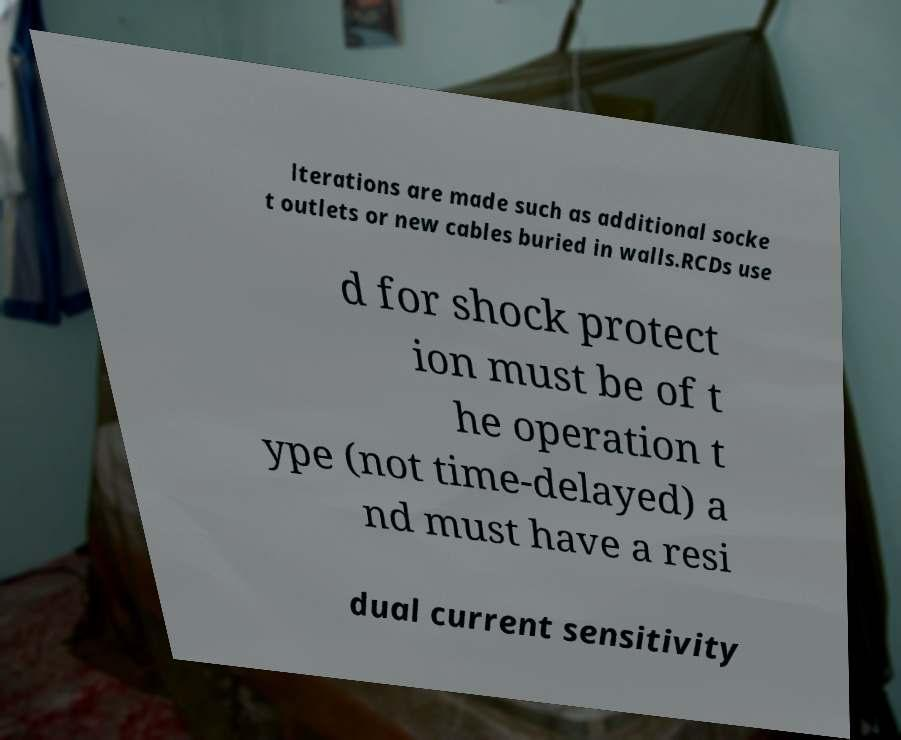I need the written content from this picture converted into text. Can you do that? lterations are made such as additional socke t outlets or new cables buried in walls.RCDs use d for shock protect ion must be of t he operation t ype (not time-delayed) a nd must have a resi dual current sensitivity 